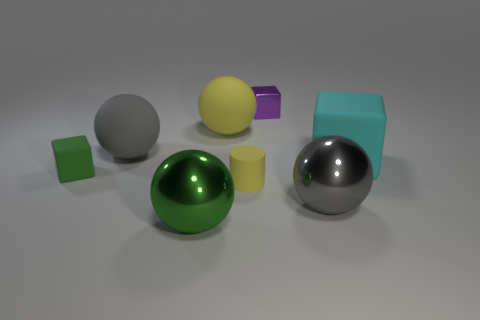Is the material of the sphere in front of the gray metallic sphere the same as the gray thing that is in front of the cyan block?
Keep it short and to the point. Yes. What number of blocks are either big cyan things or big rubber things?
Provide a short and direct response. 1. What number of shiny things are on the left side of the tiny matte thing that is to the right of the large sphere in front of the gray metallic object?
Keep it short and to the point. 1. There is a tiny purple object that is the same shape as the cyan thing; what material is it?
Provide a short and direct response. Metal. Is there any other thing that has the same material as the cyan thing?
Keep it short and to the point. Yes. There is a tiny thing that is right of the yellow matte cylinder; what color is it?
Your answer should be compact. Purple. Is the material of the yellow sphere the same as the ball on the right side of the purple thing?
Make the answer very short. No. What material is the big cyan cube?
Provide a short and direct response. Rubber. There is a green object that is made of the same material as the purple block; what shape is it?
Your answer should be very brief. Sphere. What number of other things are the same shape as the big yellow matte thing?
Your response must be concise. 3. 